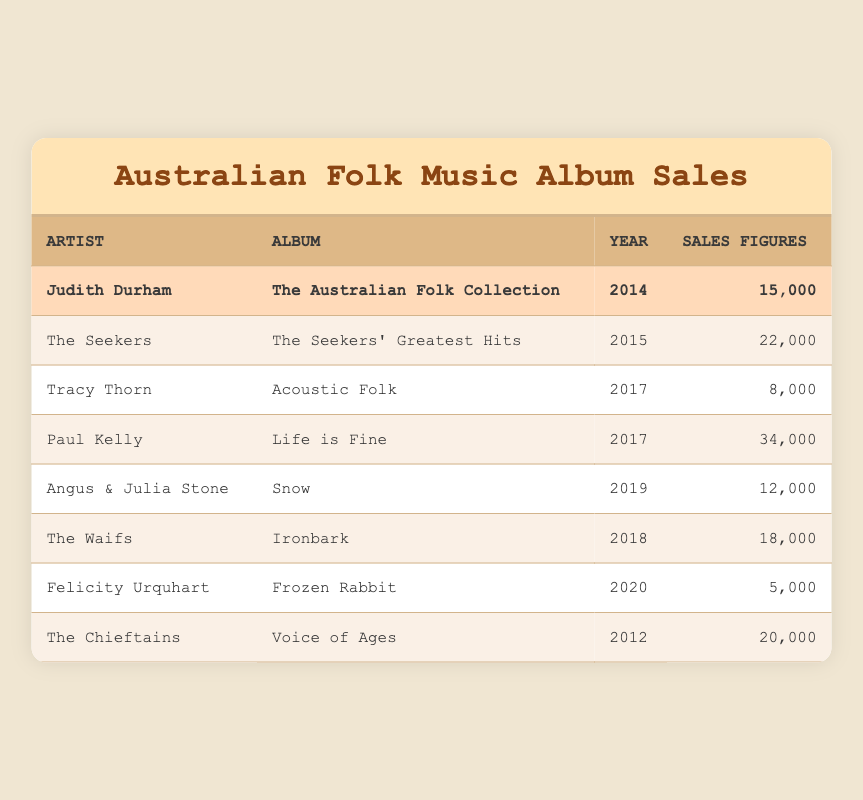What is the total sales figure for Judith Durham's album? Judith Durham's album "The Australian Folk Collection" has sales figures of 15,000. Since it is the only entry for her in the table, 15,000 is the total.
Answer: 15,000 Which artist has the highest album sales? Looking at the sales figures, Paul Kelly's "Life is Fine" has the highest sales at 34,000 when compared to other entries.
Answer: Paul Kelly What is the difference in sales figures between The Seekers and The Waifs? The Seekers' sales figures are 22,000, while The Waifs' sales figures are 18,000. The difference can be calculated as 22,000 - 18,000 = 4,000.
Answer: 4,000 How many albums in total have sales figures above 15,000? Reviewing the sales figures, the albums with sales above 15,000 are by Paul Kelly (34,000), The Seekers (22,000), and The Chieftains (20,000). This totals to three albums.
Answer: 3 Did any artist have album sales lower than 10,000? Checking the sales figures, Felicity Urquhart's "Frozen Rabbit" has sales of 5,000, which is below 10,000.
Answer: Yes What is the average sales figure of all the albums listed? The total sales figures are 15,000 + 22,000 + 8,000 + 34,000 + 12,000 + 18,000 + 5,000 + 20,000 = 134,000. There are 8 albums, so the average is 134,000 / 8 = 16,750.
Answer: 16,750 Which year had the lowest album sales, and what were those figures? The year with the lowest sales is 2020, where Felicity Urquhart's album "Frozen Rabbit" had sales figures of 5,000.
Answer: 2020, 5,000 How many albums were released after 2015? The albums released after 2015 are Paul Kelly (2017), Tracy Thorn (2017), The Waifs (2018), Angus & Julia Stone (2019), and Felicity Urquhart (2020). This sums to five albums.
Answer: 5 Which artist had the most recent album listed, and what is the sales figure? The most recent album listed is by Felicity Urquhart from 2020, which has sales figures of 5,000.
Answer: Felicity Urquhart, 5,000 